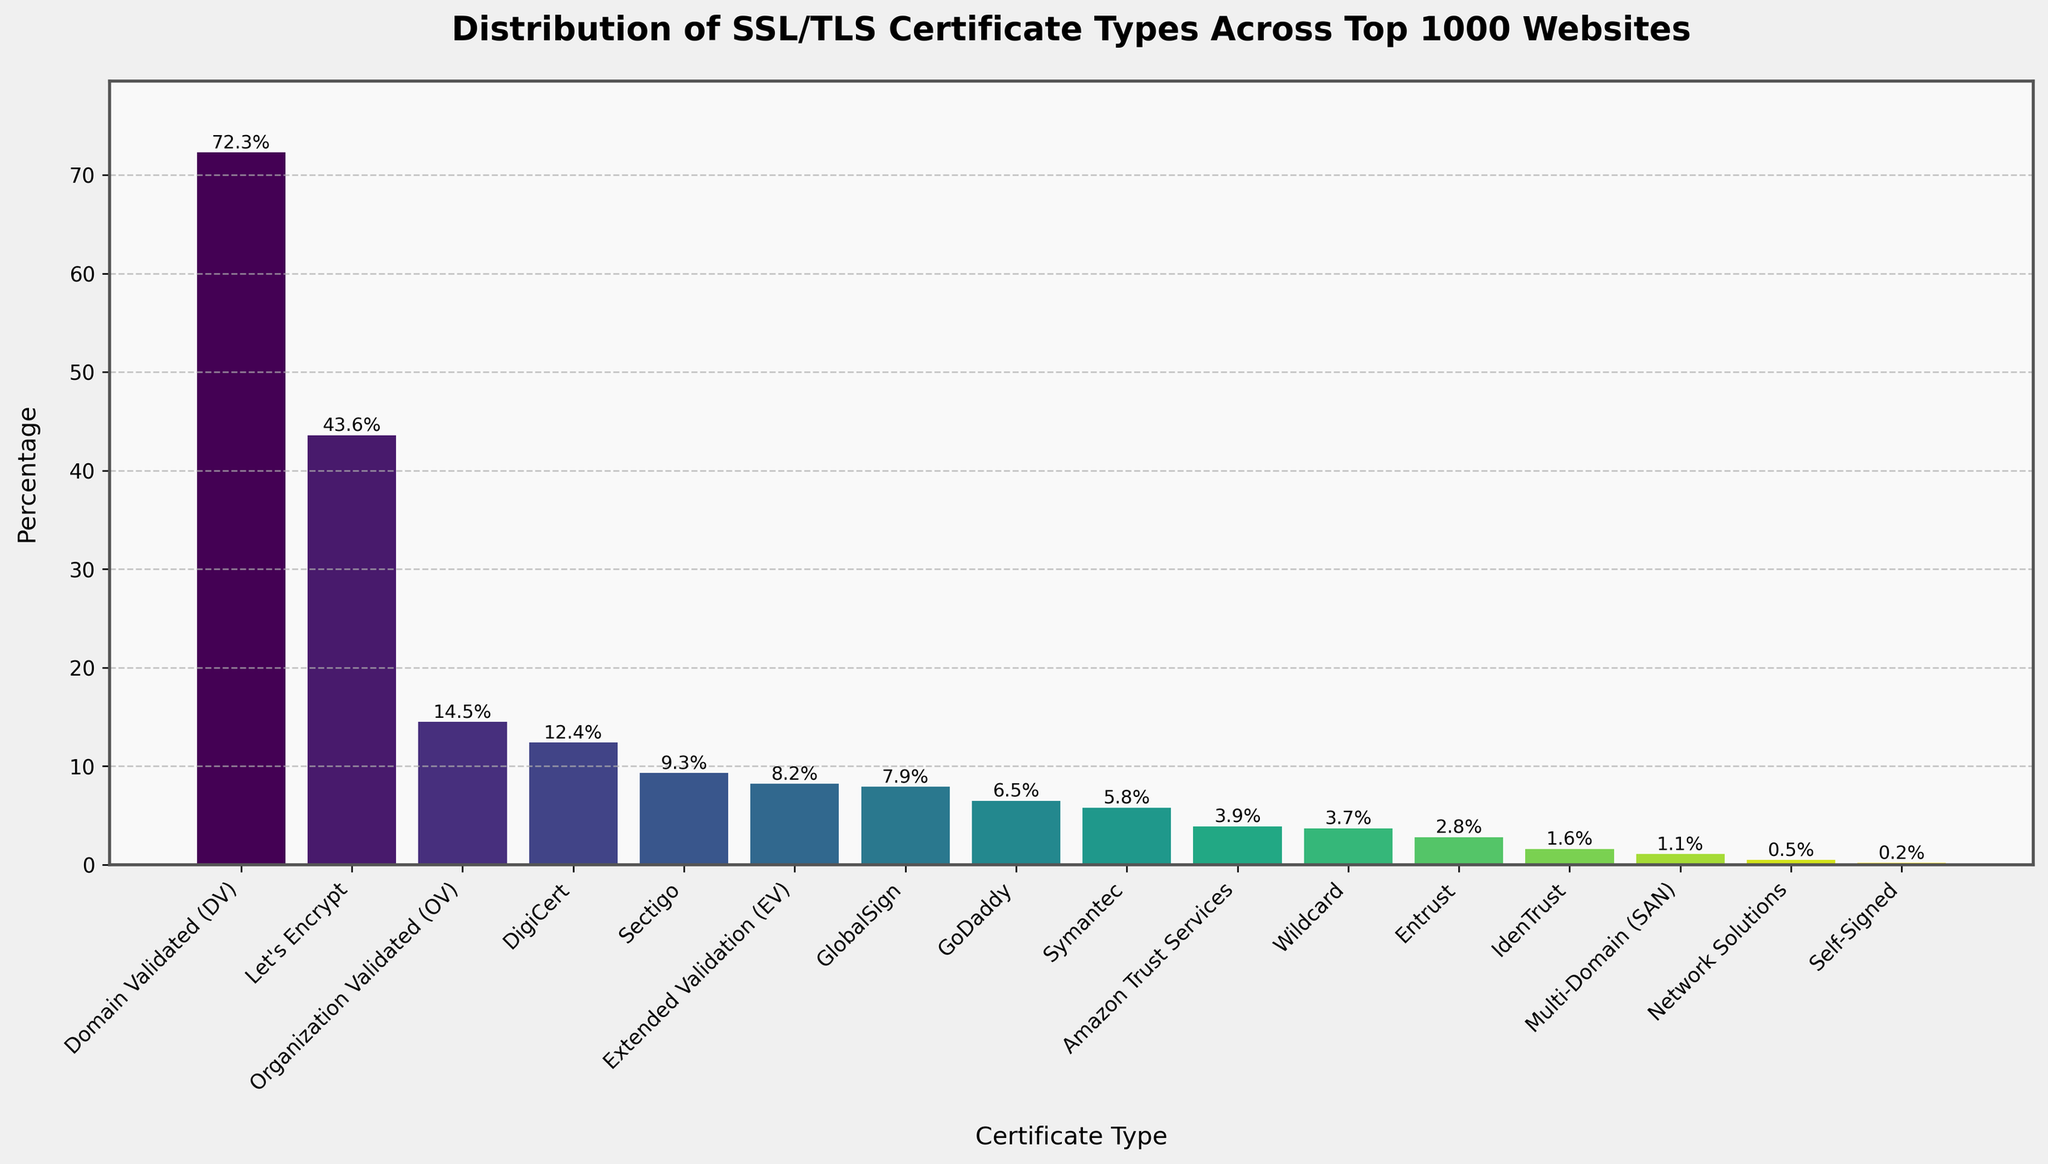Which certificate type has the highest percentage of use across the top 1000 websites? The bar chart shows the percentages of different SSL/TLS certificate types. The tallest bar represents the highest percentage.
Answer: Domain Validated (DV) Which certificate type is the least common among the top 1000 websites? The shortest bar on the chart indicates the least common certificate type.
Answer: Self-Signed How does the percentage of Let's Encrypt certificates compare to Domain Validated certificates? Locate the bars for Let's Encrypt and Domain Validated certificates. Note the percentages and compare them. Let's Encrypt is 43.6% and Domain Validated is 72.3%, making Domain Validated higher.
Answer: Less than What is the combined percentage of Extended Validation (EV) and Organization Validated (OV) certificates? Sum the percentages of EV (8.2%) and OV (14.5%) certificates: 8.2% + 14.5% = 22.7%.
Answer: 22.7% By how much does the percentage of Let's Encrypt exceed the percentage of Symantec certificates? Subtract the percentage of Symantec (5.8%) from Let's Encrypt (43.6%): 43.6% - 5.8% = 37.8%.
Answer: 37.8% Which two certificate types have percentages closest to each other? Identify the bars with similar lengths. Closest are Amazon Trust Services (3.9%) and Wildcard (3.7%). The difference is only: 3.9% - 3.7% = 0.2%.
Answer: Amazon Trust Services and Wildcard Are there more websites with certificates from Let's Encrypt or from GlobalSign and Sectigo combined? Compare the percentage of Let's Encrypt (43.6%) to the sum of GlobalSign (7.9%) and Sectigo (9.3%) combined: 7.9% + 9.3% = 17.2%. 43.6% is greater than 17.2%.
Answer: Let's Encrypt What is the total percentage for the top three most common certificate types? Sum the percentages of the top three certificate types: Domain Validated (72.3%), Let's Encrypt (43.6%), and Organization Validated (14.5%). Total = 72.3% + 43.6% + 14.5% = 130.4%.
Answer: 130.4% Which certificate type has a higher percentage: GoDaddy or Amazon Trust Services? Locate the bars for GoDaddy (6.5%) and Amazon Trust Services (3.9%), and compare the percentages.
Answer: GoDaddy Is the percentage of "Wildcard" certificates greater than the percentage of "DigiCert" certificates? Locate the bars for Wildcard (3.7%) and DigiCert (12.4%). Comparing them shows DigiCert has a higher percentage.
Answer: No 